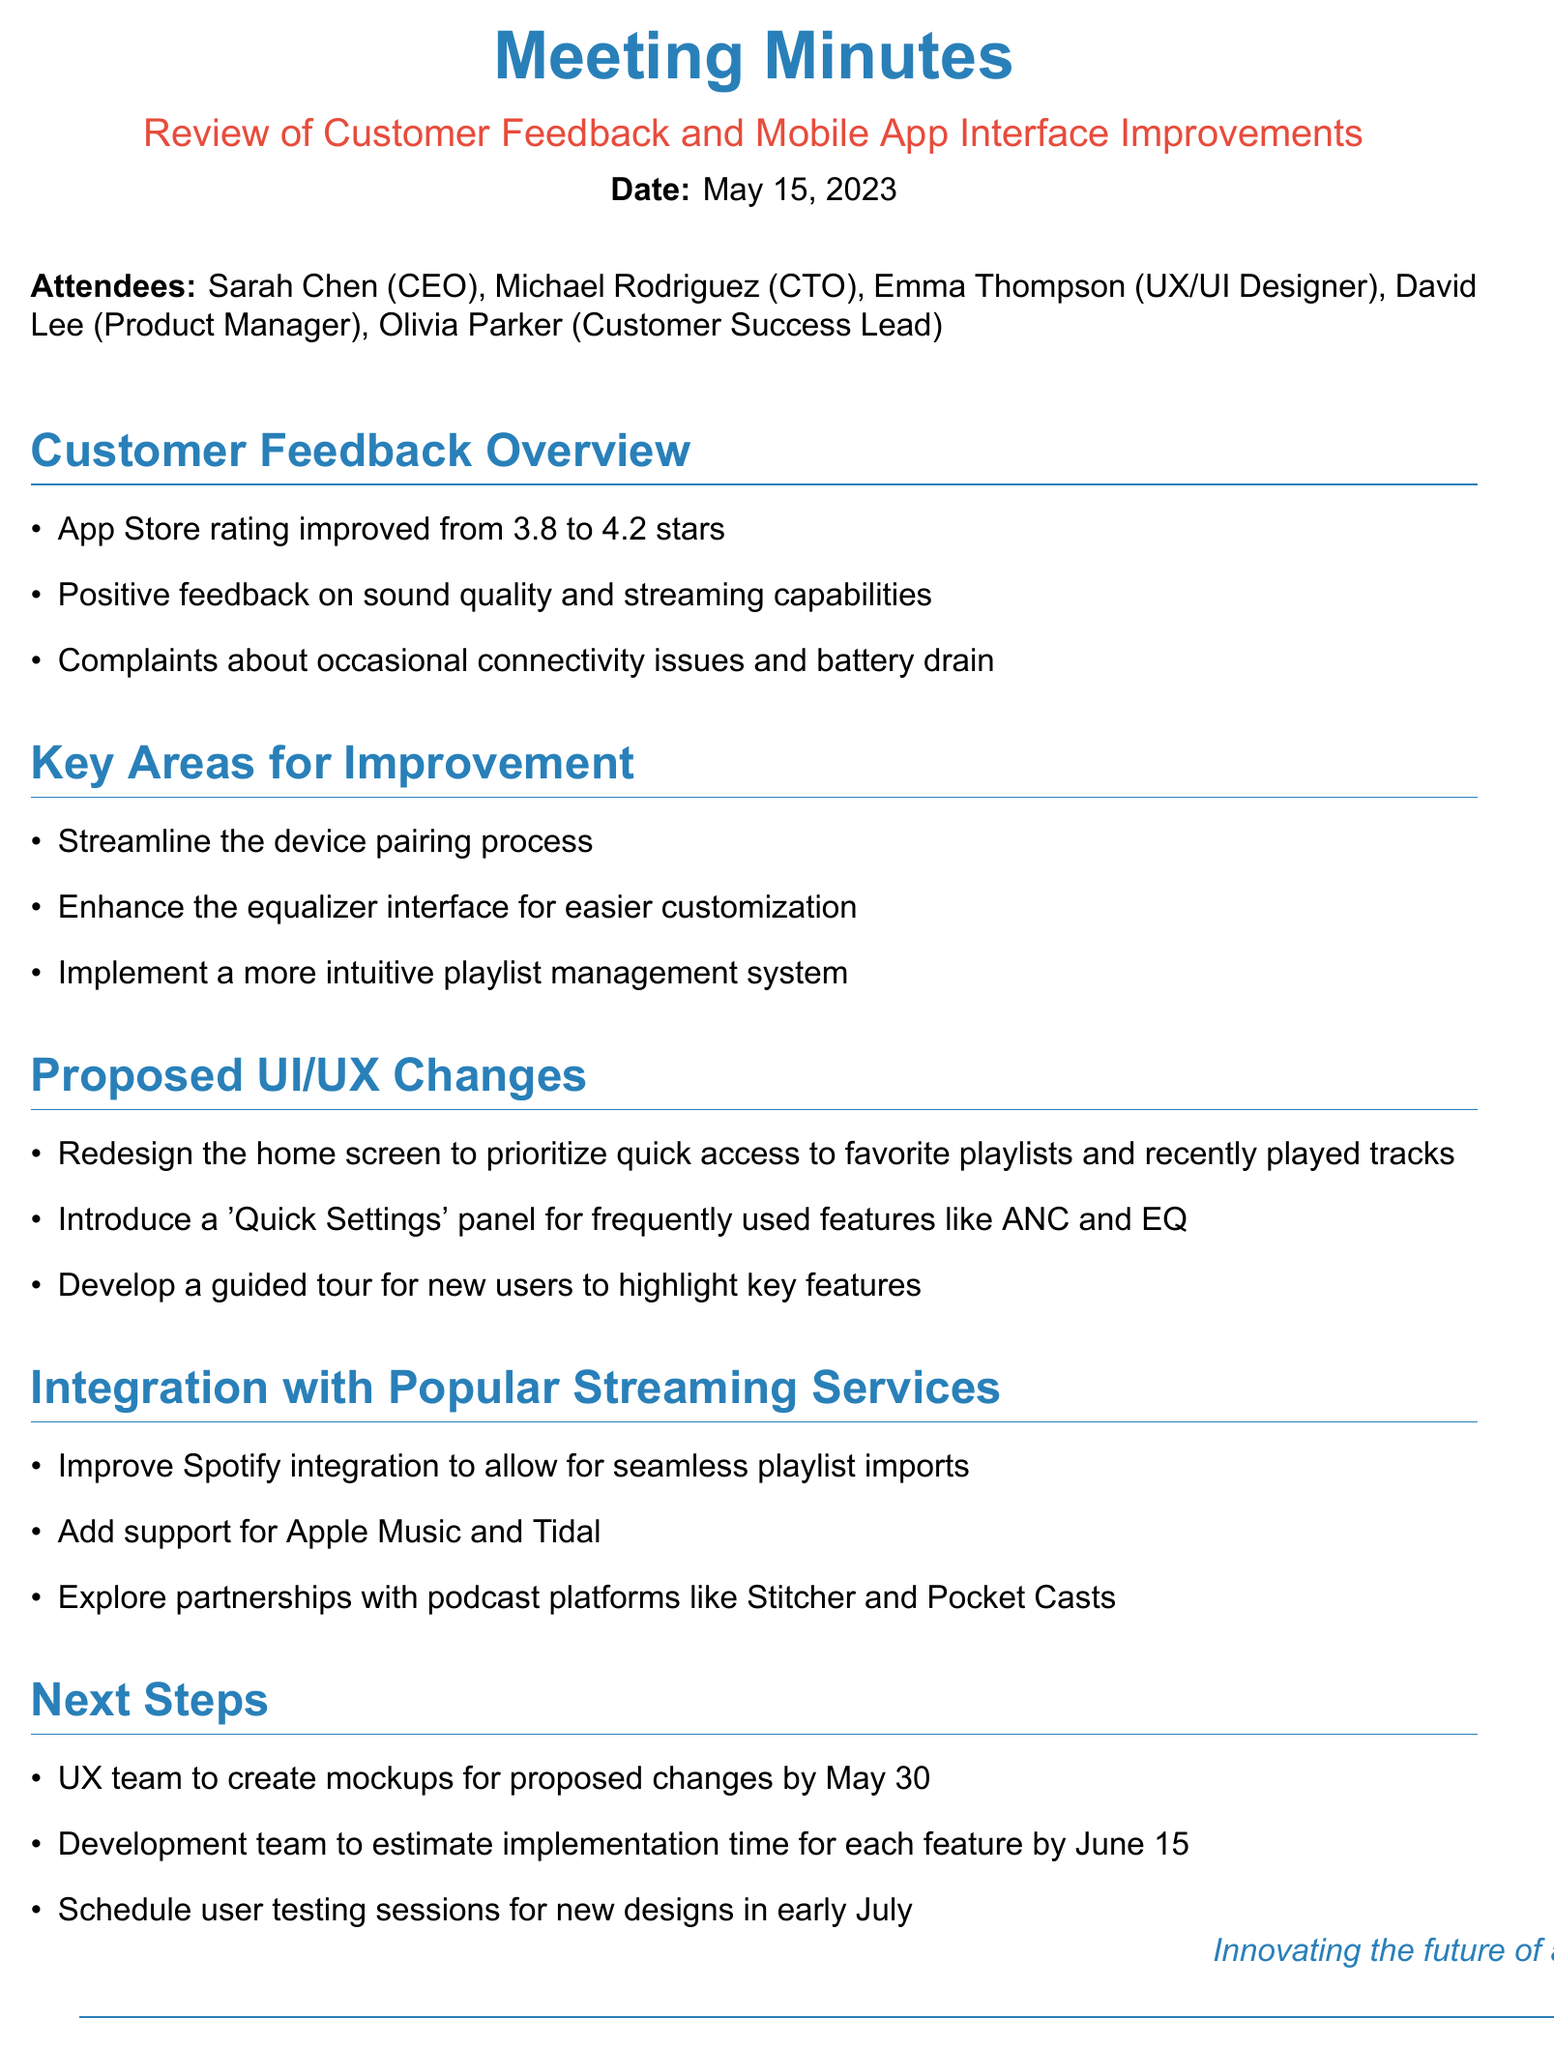What was the App Store rating before the improvement? The document states the App Store rating improved from 3.8 stars.
Answer: 3.8 stars What is one positive feedback highlight about the app? The feedback mentioned in the document highlights that there is positive feedback on sound quality.
Answer: sound quality What is the proposed completion date for the UX team's mockups? The document specifies that the UX team is to create mockups for proposed changes by May 30.
Answer: May 30 Which streaming services are mentioned for potential integration? The document lists Spotify, Apple Music, and Tidal as streaming services for potential integration.
Answer: Spotify, Apple Music, Tidal What is one of the key areas identified for improvement? The document identifies the need to streamline the device pairing process as a key area for improvement.
Answer: streamline the device pairing process What will the development team estimate by June 15? According to the document, the development team will estimate implementation time for each feature by June 15.
Answer: implementation time What feature will be introduced for frequently used settings? The document proposes a 'Quick Settings' panel for frequently used features.
Answer: 'Quick Settings' panel Which feature aims to assist new users? The document mentions developing a guided tour for new users to highlight key features.
Answer: guided tour What was the main theme of the meeting? The document focuses on reviewing customer feedback and potential improvements for the mobile app interface.
Answer: Customer feedback and mobile app interface improvements 